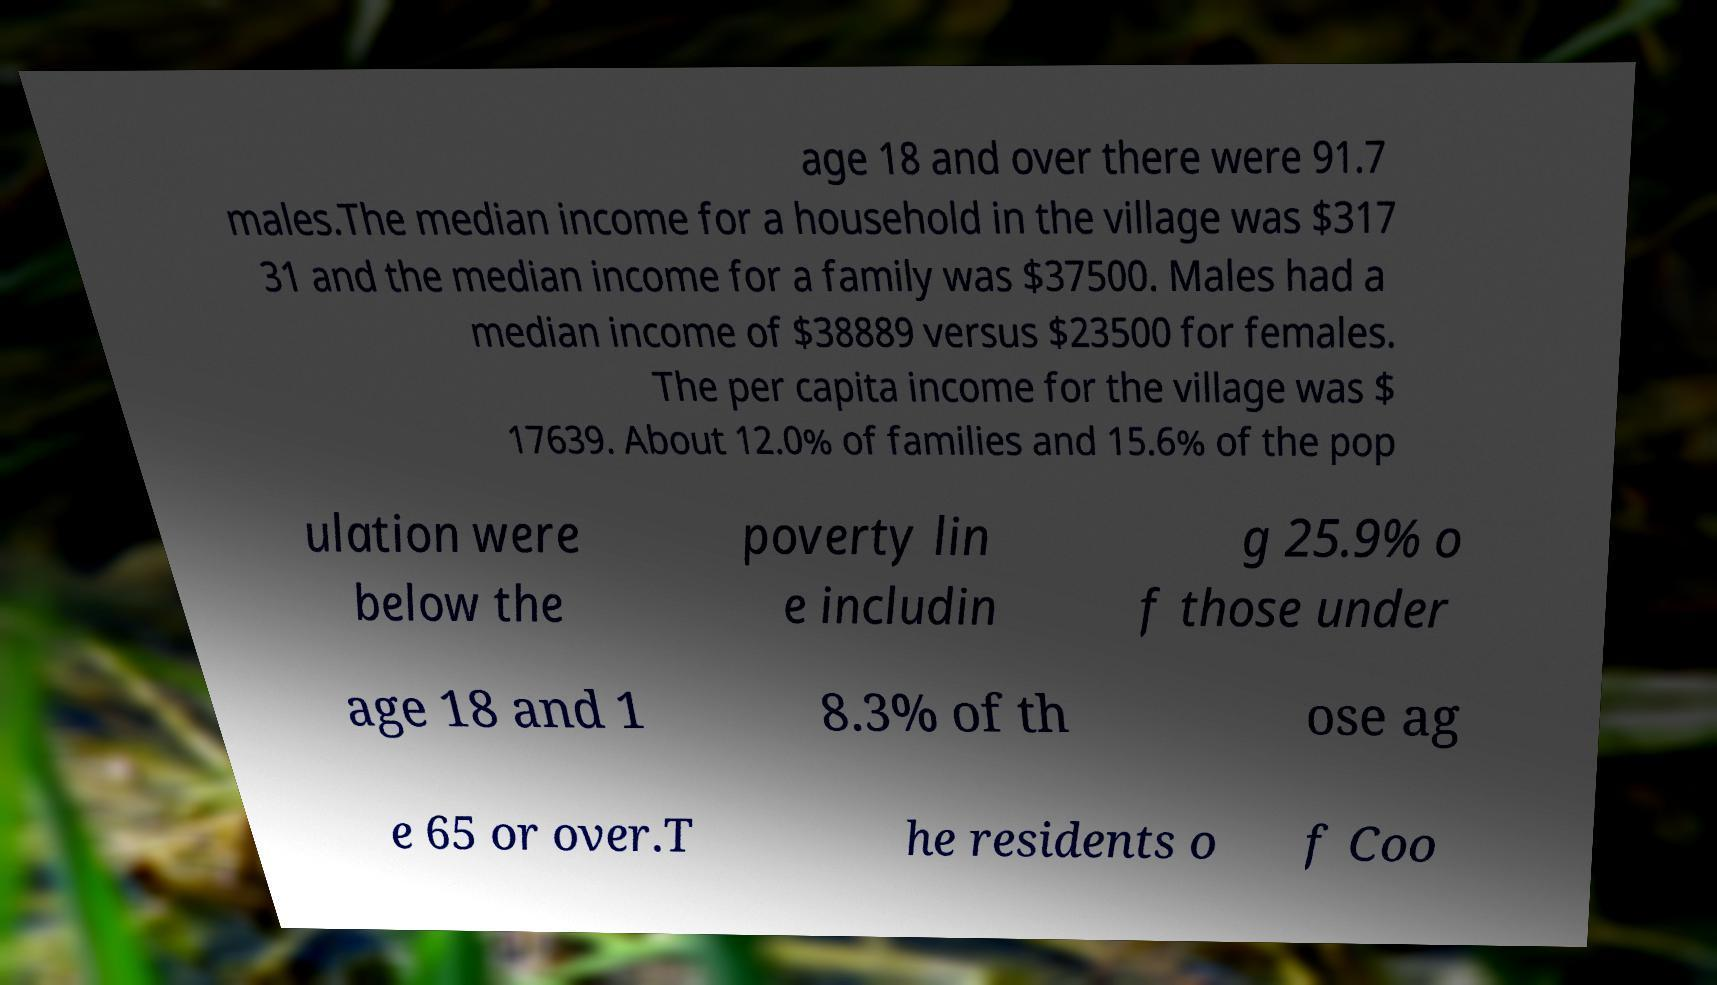What messages or text are displayed in this image? I need them in a readable, typed format. age 18 and over there were 91.7 males.The median income for a household in the village was $317 31 and the median income for a family was $37500. Males had a median income of $38889 versus $23500 for females. The per capita income for the village was $ 17639. About 12.0% of families and 15.6% of the pop ulation were below the poverty lin e includin g 25.9% o f those under age 18 and 1 8.3% of th ose ag e 65 or over.T he residents o f Coo 